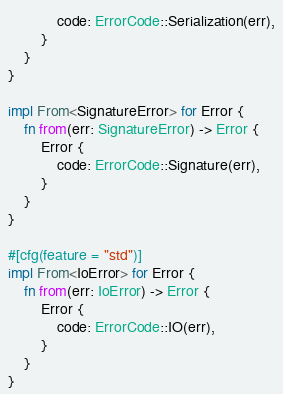Convert code to text. <code><loc_0><loc_0><loc_500><loc_500><_Rust_>            code: ErrorCode::Serialization(err),
        }
    }
}

impl From<SignatureError> for Error {
    fn from(err: SignatureError) -> Error {
        Error {
            code: ErrorCode::Signature(err),
        }
    }
}

#[cfg(feature = "std")]
impl From<IoError> for Error {
    fn from(err: IoError) -> Error {
        Error {
            code: ErrorCode::IO(err),
        }
    }
}
</code> 